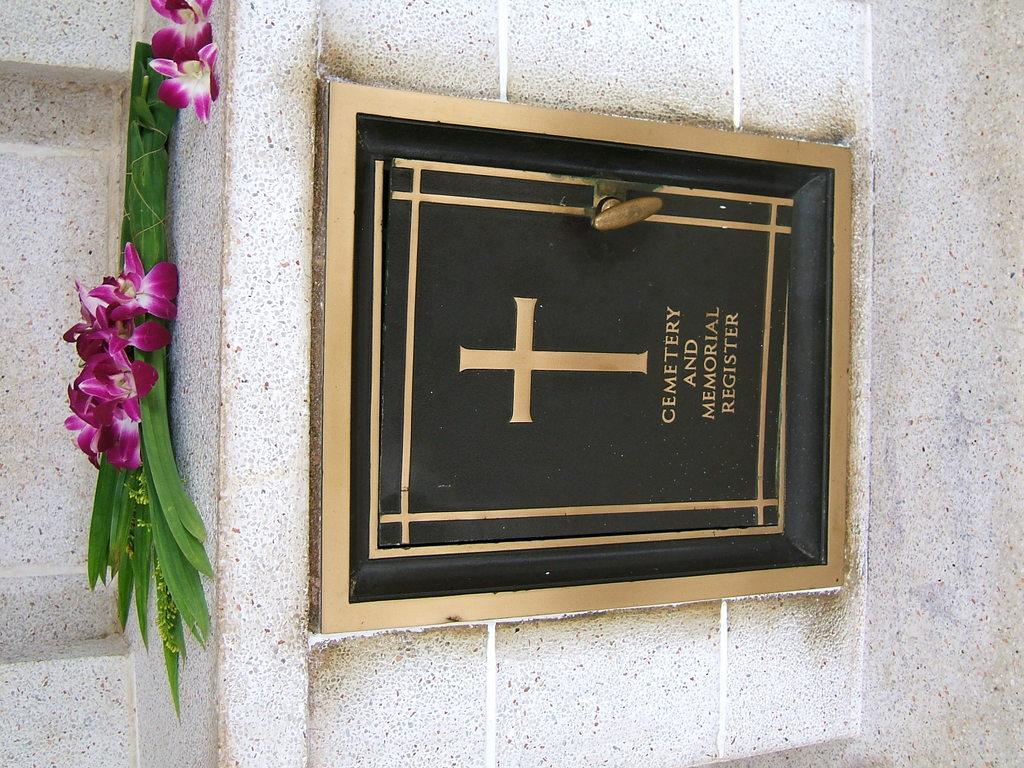<image>
Provide a brief description of the given image. flowers placed above a gold and black plaque for a cemetary and memorial register 